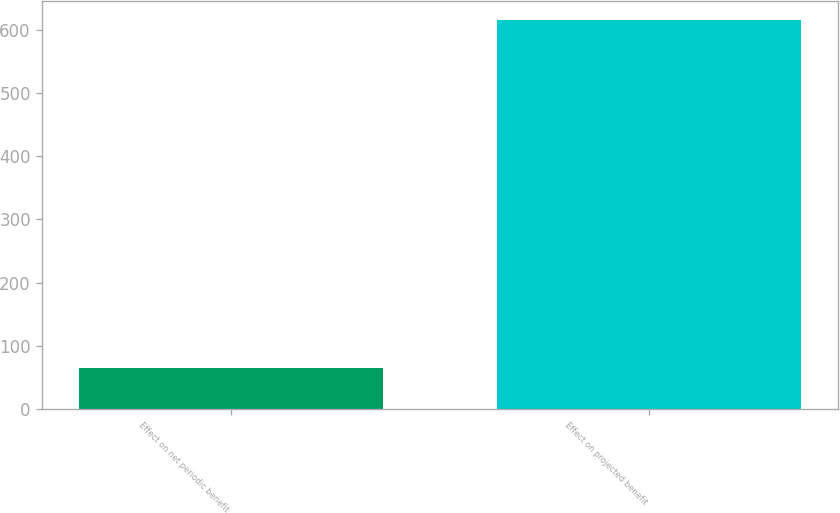<chart> <loc_0><loc_0><loc_500><loc_500><bar_chart><fcel>Effect on net periodic benefit<fcel>Effect on projected benefit<nl><fcel>65<fcel>615<nl></chart> 